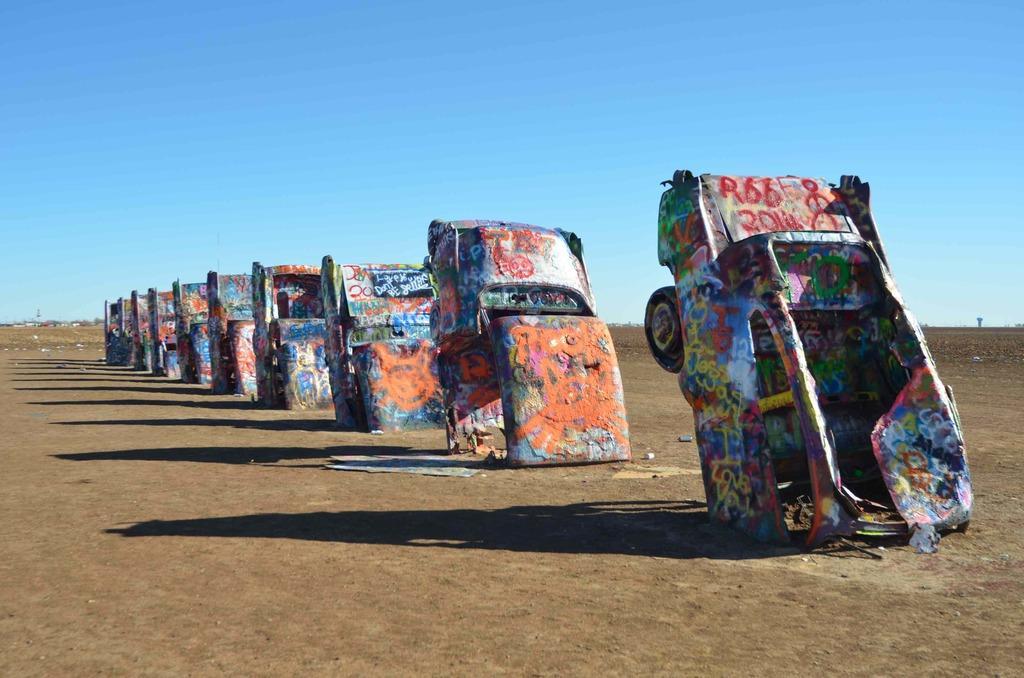Can you describe this image briefly? In the center of the image we can see trucks are present. At the top of the image sky is there. At the bottom of the image ground is present. 